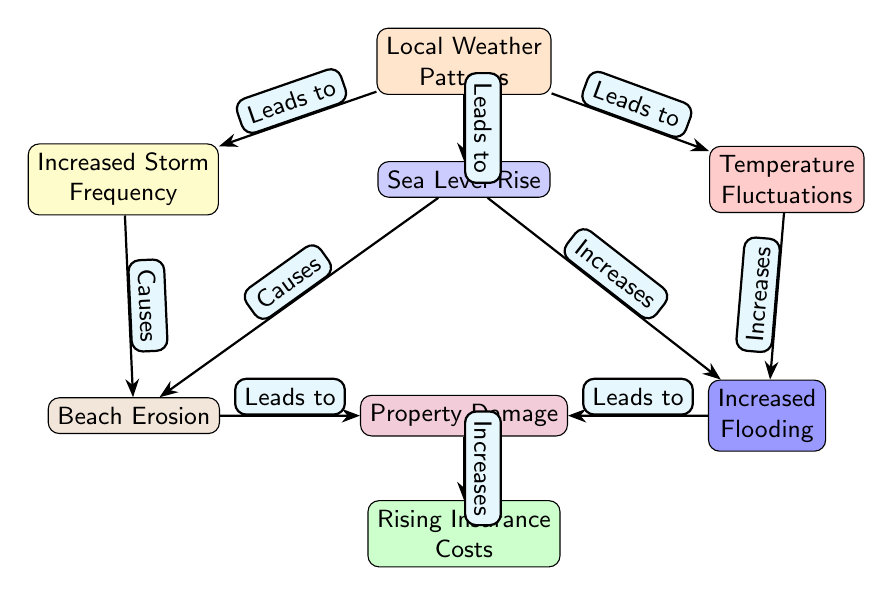What are the three primary factors listed that influence local weather patterns? The diagram identifies three primary factors leading to changes in local weather patterns: Increased Storm Frequency, Sea Level Rise, and Temperature Fluctuations. These factors are clearly labeled as the major contributors in the first row of nodes in the diagram.
Answer: Increased Storm Frequency, Sea Level Rise, Temperature Fluctuations How many secondary impacts are shown stemming from Sea Level Rise? From the diagram, it can be observed that Sea Level Rise leads to two secondary impacts: Beach Erosion and Increased Flooding. Each of these is represented by a node connected to the Sea Level Rise node, indicating its influence.
Answer: 2 What is the final impact that results from Property Damage? The diagram indicates that Property Damage results in Rising Insurance Costs. This connection shows how the consequences of property damage lead to increased financial burdens for property owners, represented as the final node.
Answer: Rising Insurance Costs Which event causes Beach Erosion as per the diagram? Beach Erosion is caused by two sources, Increased Storm Frequency and Sea Level Rise. The diagram explicitly shows arrows pointing from both of these nodes to Beach Erosion, indicating their causal relationship.
Answer: Increased Storm Frequency, Sea Level Rise How does Temperature Fluctuation affect flooding according to the diagram? Temperature Fluctuation increases flooding as evidenced by the arrow connecting the Temperature Fluctuations node to the Increased Flooding node. This shows a direct relationship, where fluctuations in temperature contribute to the likelihood and severity of flooding.
Answer: Increases 